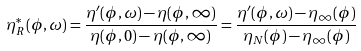Convert formula to latex. <formula><loc_0><loc_0><loc_500><loc_500>\eta ^ { * } _ { R } ( \phi , \omega ) = \frac { \eta ^ { \prime } ( \phi , \omega ) - \eta ( \phi , \infty ) } { \eta ( \phi , 0 ) - \eta ( \phi , \infty ) } = \frac { \eta ^ { \prime } ( \phi , \omega ) - \eta _ { \infty } ( \phi ) } { \eta _ { N } ( \phi ) - \eta _ { \infty } ( \phi ) }</formula> 